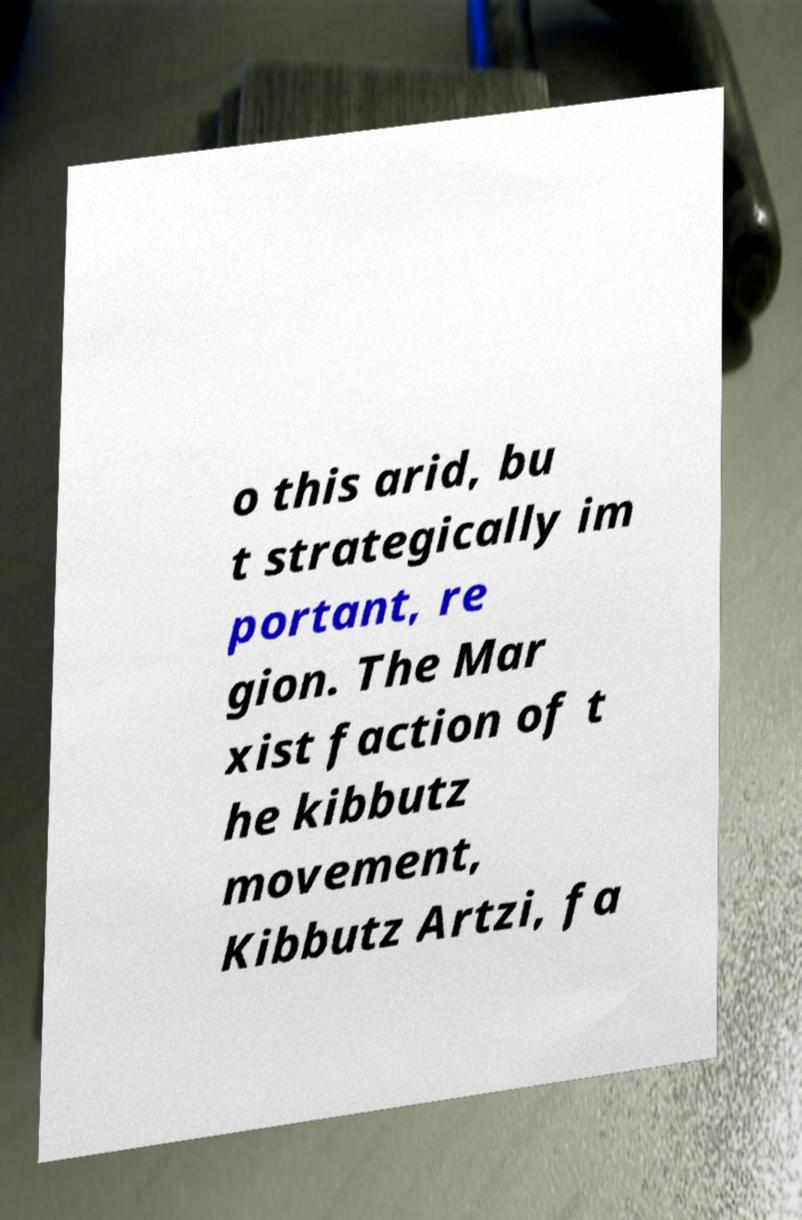Please read and relay the text visible in this image. What does it say? o this arid, bu t strategically im portant, re gion. The Mar xist faction of t he kibbutz movement, Kibbutz Artzi, fa 